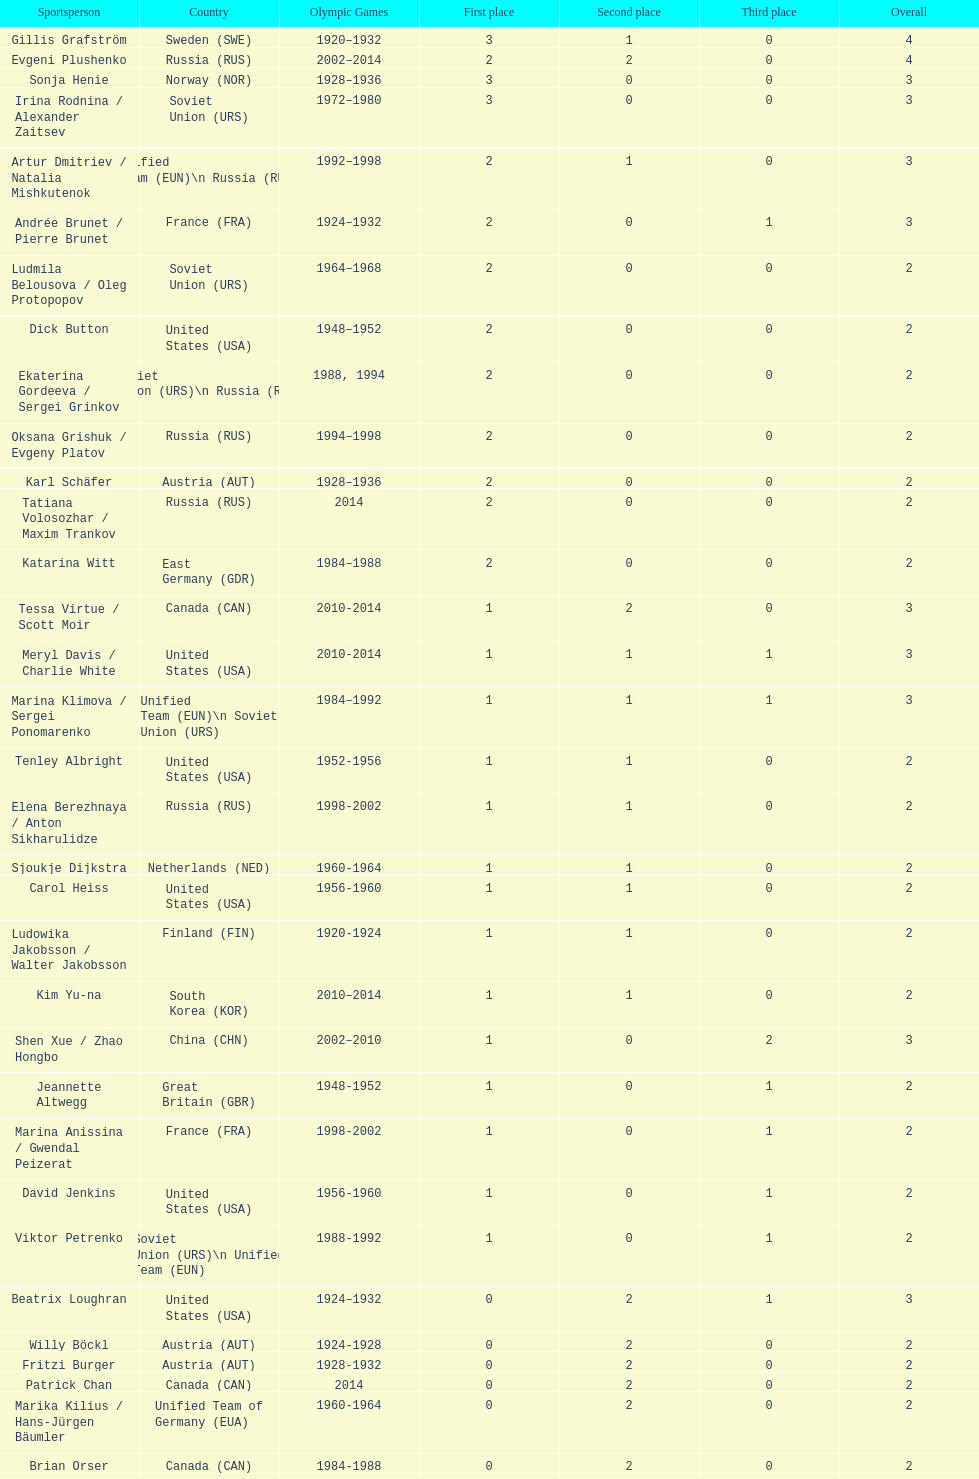How many medals have sweden and norway won combined? 7. 